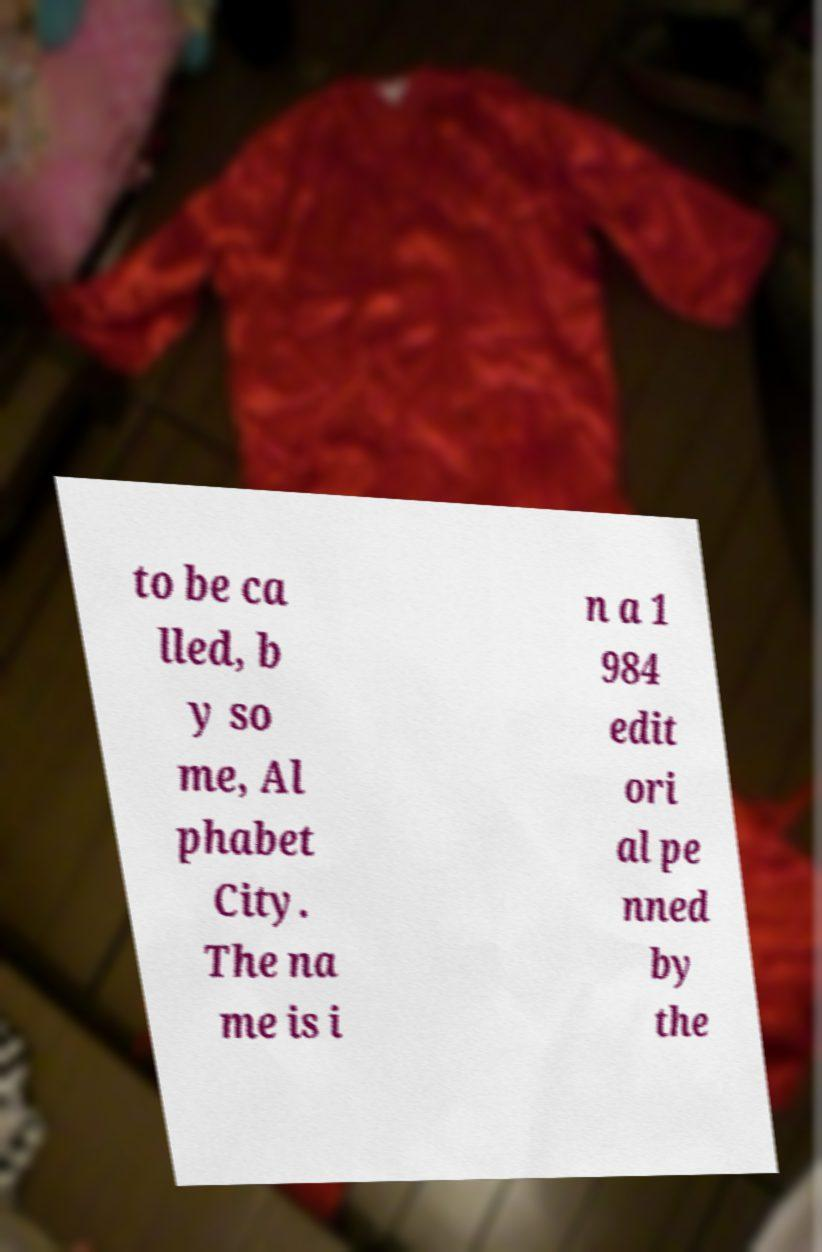What messages or text are displayed in this image? I need them in a readable, typed format. to be ca lled, b y so me, Al phabet City. The na me is i n a 1 984 edit ori al pe nned by the 